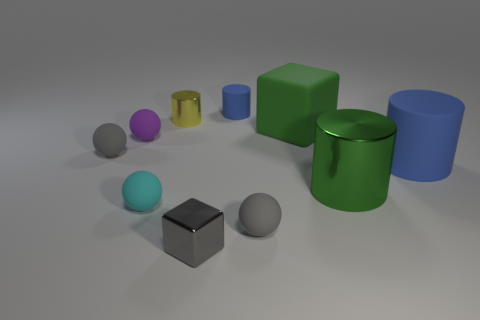Are there more big green cylinders that are right of the small purple rubber sphere than big blue objects that are in front of the big green metal thing?
Make the answer very short. Yes. How many big objects are made of the same material as the small yellow cylinder?
Provide a succinct answer. 1. Do the matte block and the cyan matte ball have the same size?
Your answer should be compact. No. What color is the big shiny cylinder?
Offer a terse response. Green. How many objects are matte objects or small cyan things?
Provide a succinct answer. 7. Is there a tiny gray shiny thing that has the same shape as the small purple object?
Your answer should be very brief. No. There is a small metallic object on the left side of the gray metallic cube; is its color the same as the shiny block?
Make the answer very short. No. The gray rubber thing to the left of the metallic cylinder that is behind the big metal cylinder is what shape?
Give a very brief answer. Sphere. Are there any green metal balls of the same size as the green cylinder?
Offer a very short reply. No. Are there fewer yellow objects than big blue blocks?
Ensure brevity in your answer.  No. 